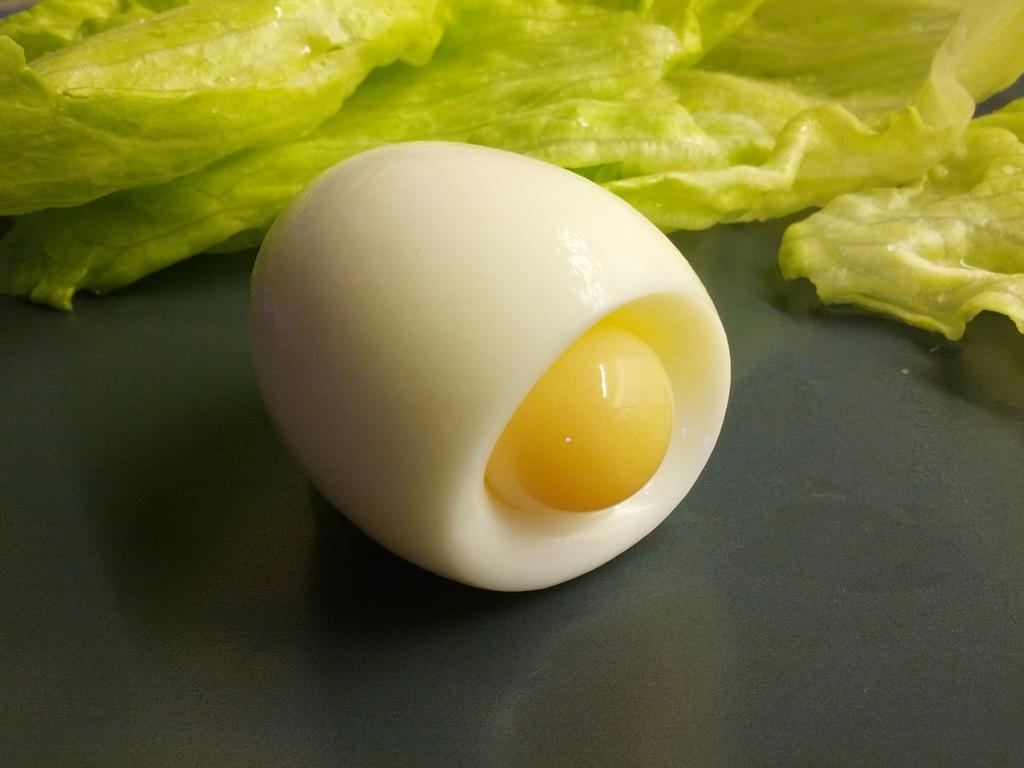Could you give a brief overview of what you see in this image? In this image in the center there is one egg which is boiled, and in the background there are some cabbage leaves. At the bottom it looks like a plate. 